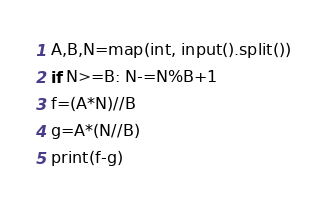Convert code to text. <code><loc_0><loc_0><loc_500><loc_500><_Python_>A,B,N=map(int, input().split())
if N>=B: N-=N%B+1
f=(A*N)//B
g=A*(N//B)
print(f-g)
</code> 